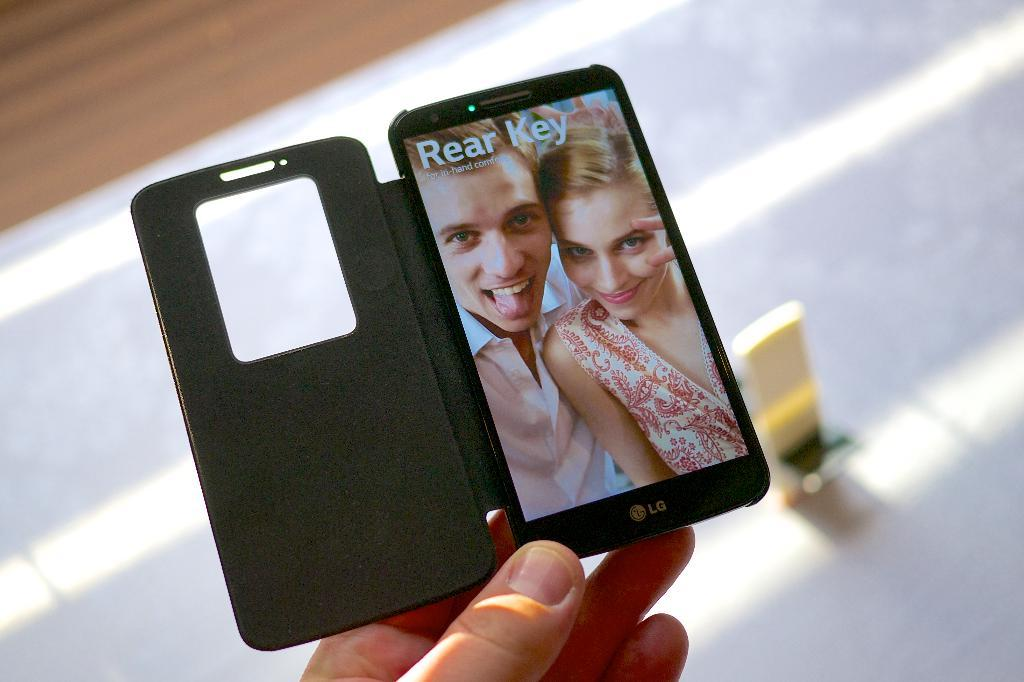Provide a one-sentence caption for the provided image. an LG phone with a boy and girl along with the words Rear Key. 